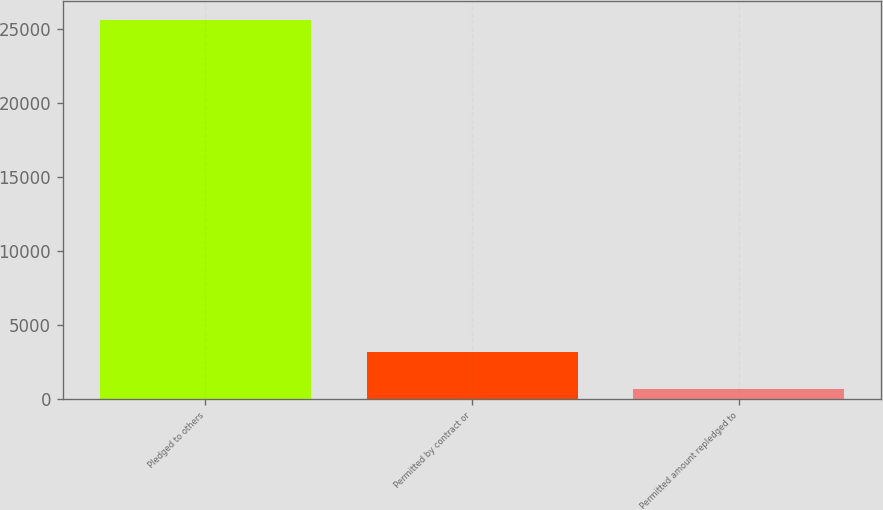Convert chart. <chart><loc_0><loc_0><loc_500><loc_500><bar_chart><fcel>Pledged to others<fcel>Permitted by contract or<fcel>Permitted amount repledged to<nl><fcel>25648<fcel>3181.3<fcel>685<nl></chart> 